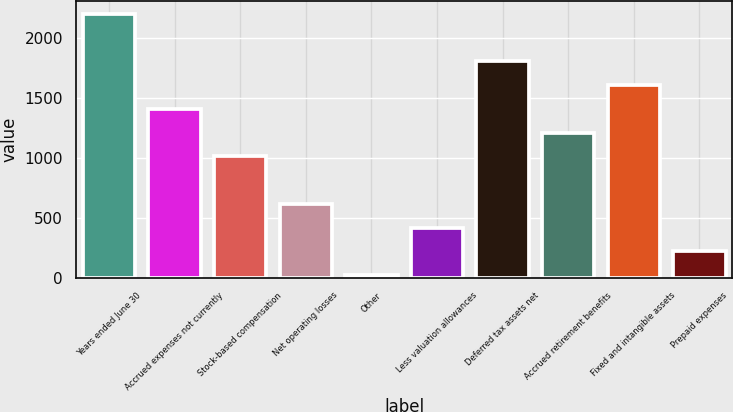Convert chart to OTSL. <chart><loc_0><loc_0><loc_500><loc_500><bar_chart><fcel>Years ended June 30<fcel>Accrued expenses not currently<fcel>Stock-based compensation<fcel>Net operating losses<fcel>Other<fcel>Less valuation allowances<fcel>Deferred tax assets net<fcel>Accrued retirement benefits<fcel>Fixed and intangible assets<fcel>Prepaid expenses<nl><fcel>2205.73<fcel>1410.81<fcel>1013.35<fcel>615.89<fcel>19.7<fcel>417.16<fcel>1808.27<fcel>1212.08<fcel>1609.54<fcel>218.43<nl></chart> 